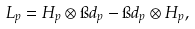<formula> <loc_0><loc_0><loc_500><loc_500>L _ { p } = H _ { p } \otimes \i d _ { p } - \i d _ { p } \otimes H _ { p } ,</formula> 